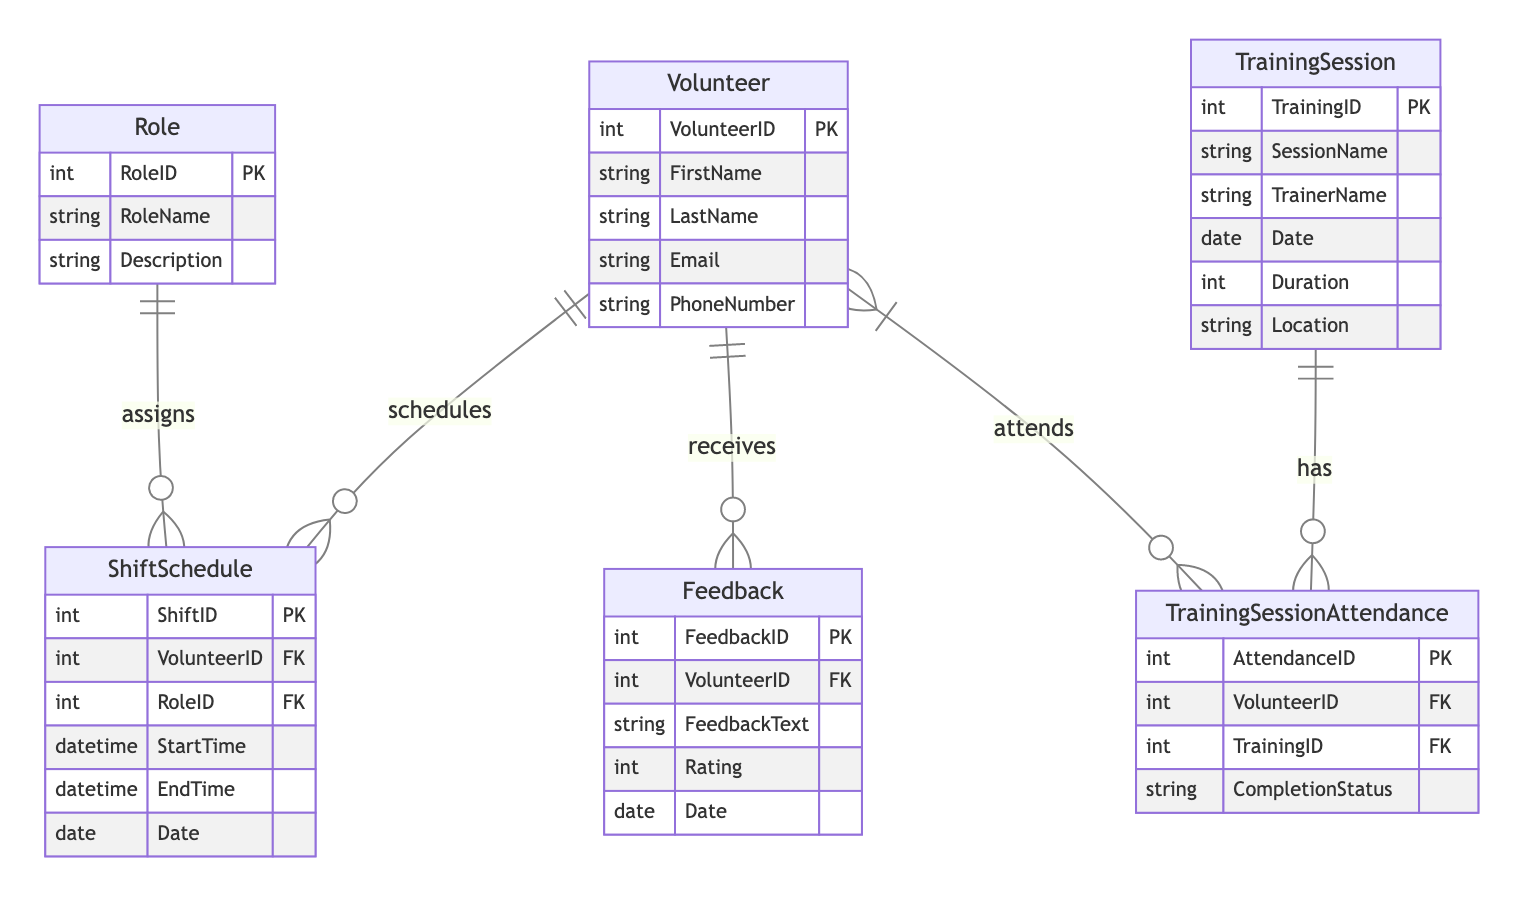What is the primary key of the Volunteer entity? The primary key, as indicated in the diagram, is a unique identifier for each volunteer, which is labeled as "VolunteerID."
Answer: VolunteerID How many entities are in the diagram? The diagram includes five entities: Volunteer, Role, Shift Schedule, Training Session, and Feedback, which can be counted directly from the "entities" section.
Answer: Five What type of relationship exists between Volunteer and Shift Schedule? The diagram shows a one-to-many relationship from Volunteer to Shift Schedule, indicating that one volunteer can be scheduled for multiple shifts.
Answer: One-to-many How many attributes does the Role entity have? The Role entity is listed with three attributes: RoleID, RoleName, and Description. This can be seen directly in the "attributes" section of the Role entity.
Answer: Three What entity tracks the performance of volunteers? The Feedback entity is responsible for tracking the performance, as it includes attributes related to feedback from volunteers.
Answer: Feedback How many roles can a single volunteer have? A single volunteer can have multiple roles, as indicated by the many-to-many relationship between Volunteer and Role through the Shift Schedule.
Answer: Multiple What is the primary key of the Training Session entity? The primary key for the Training Session entity, which uniquely identifies each training event, is labeled as "TrainingID."
Answer: TrainingID What is the relationship type between Training Session and Training Session Attendance? The diagram indicates a one-to-many relationship between Training Session and Training Session Attendance, signifying that each training session can have multiple attendance records.
Answer: One-to-many What is the purpose of the TrainingSessionAttendance junction table? The junction table serves to facilitate the many-to-many relationship between Volunteer and Training Session by keeping track of which volunteers attended specific training sessions.
Answer: Track attendance 